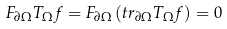Convert formula to latex. <formula><loc_0><loc_0><loc_500><loc_500>F _ { \partial \Omega } T _ { \Omega } f = F _ { \partial \Omega } \left ( t r _ { \partial \Omega } T _ { \Omega } f \right ) = 0</formula> 